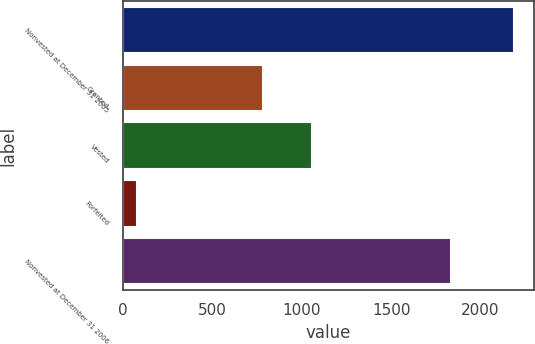Convert chart to OTSL. <chart><loc_0><loc_0><loc_500><loc_500><bar_chart><fcel>Nonvested at December 31 2005<fcel>Granted<fcel>Vested<fcel>Forfeited<fcel>Nonvested at December 31 2006<nl><fcel>2187<fcel>781<fcel>1055<fcel>80<fcel>1833<nl></chart> 